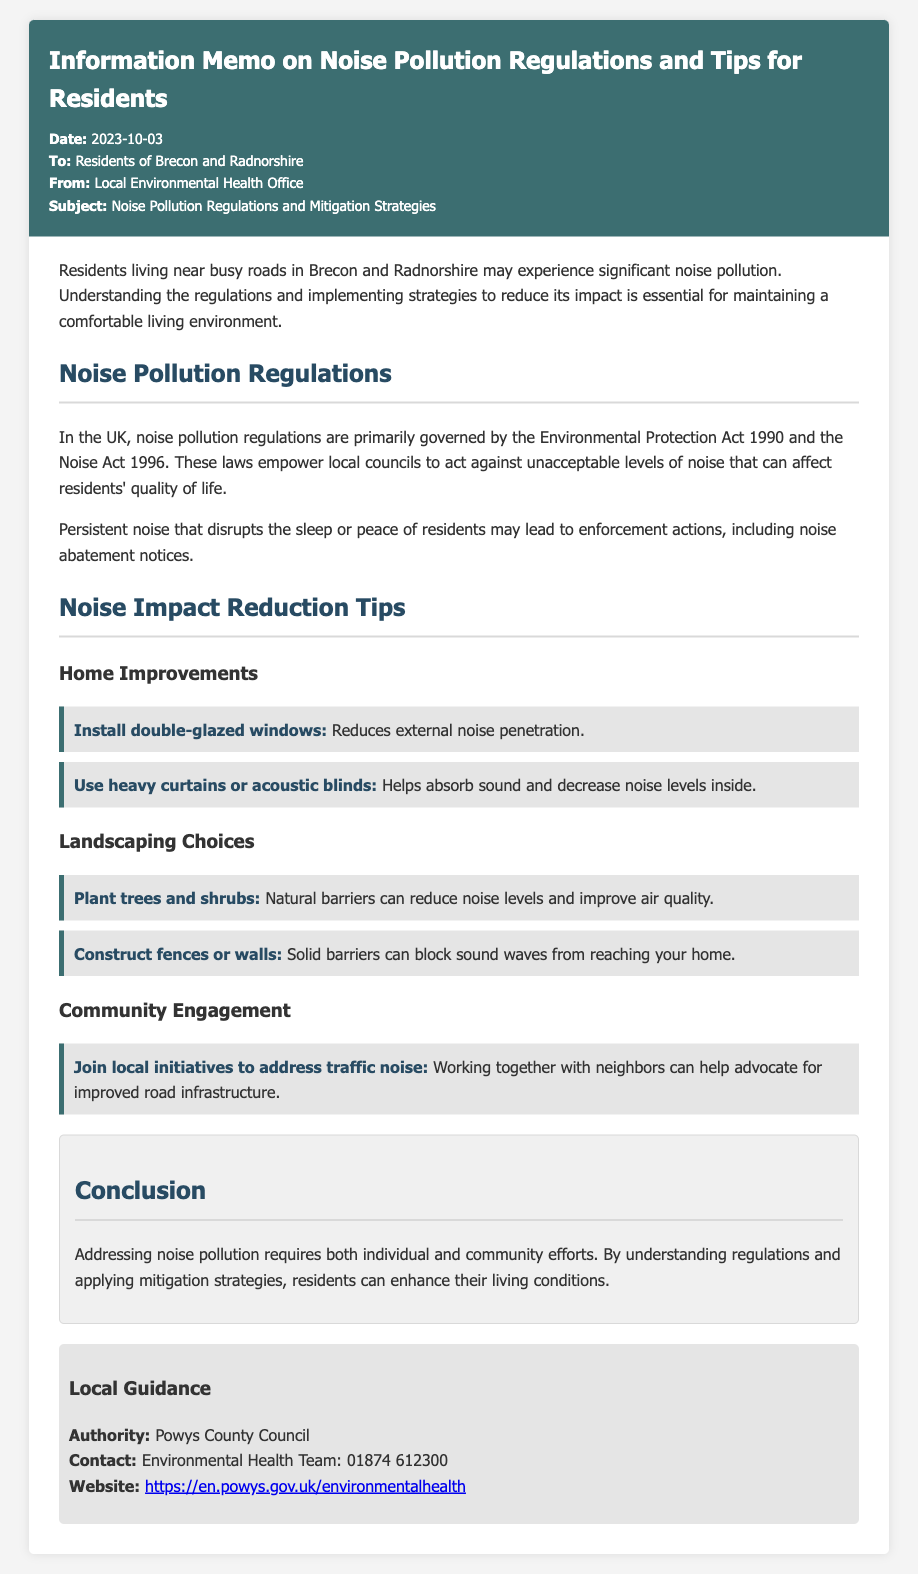what is the subject of the memo? The subject of the memo is stated in the title section, highlighting the main focus of the document.
Answer: Noise Pollution Regulations and Mitigation Strategies who is the memo addressed to? The recipient of the memo is specified in the introductory section, indicating the audience intended for the document.
Answer: Residents of Brecon and Radnorshire what date was the memo issued? The date of issuance is included in the meta information at the top of the memo, representing when this document was created.
Answer: 2023-10-03 what are the two main laws mentioned regarding noise pollution? The laws governing noise pollution are specified in the regulations section, indicating the legal framework in place.
Answer: Environmental Protection Act 1990 and Noise Act 1996 what is one suggestion for home improvement to reduce noise? The tips for noise reduction in homes provide recommended actions that residents can take to minimize noise impact.
Answer: Install double-glazed windows which local authority is mentioned in the contact information? The authority responsible for local guidance is indicated in the contact section, which provides essential communication details for residents.
Answer: Powys County Council how can residents engage with their community to address traffic noise? The community engagement section includes actions that residents can take collectively to address local issues.
Answer: Join local initiatives to address traffic noise what type of noise barriers can be created through landscaping choices? The landscaping choices section contains recommendations for natural solutions that can help with noise reduction.
Answer: Plant trees and shrubs what is one type of window treatment suggested to absorb sound? The document provides suggestions for reducing noise levels inside homes, specifically regarding window treatments.
Answer: Use heavy curtains or acoustic blinds 